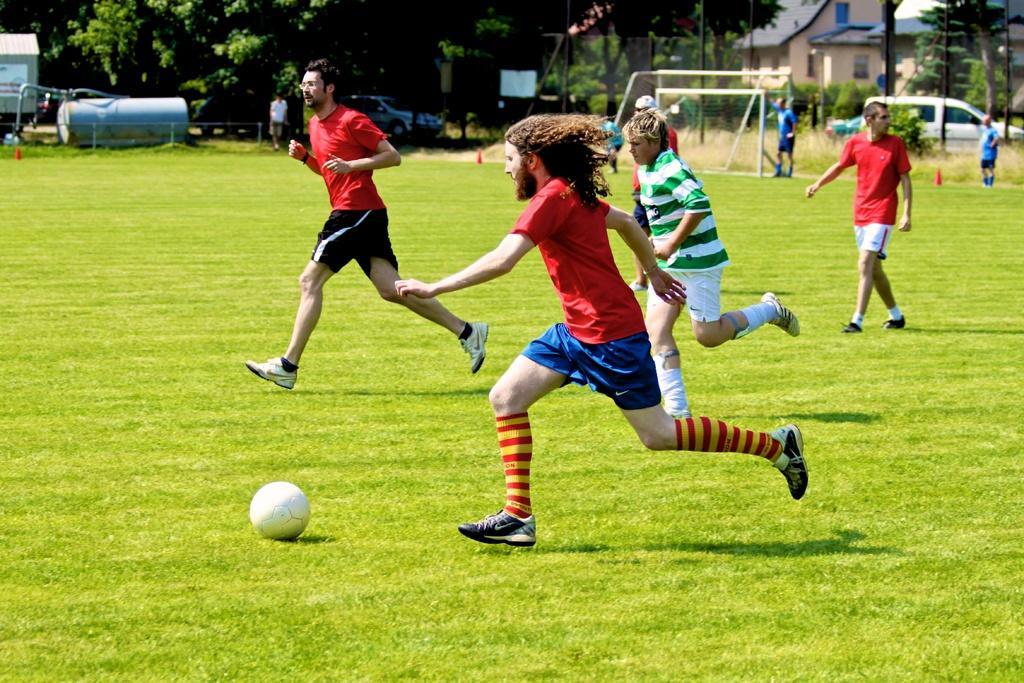How would you summarize this image in a sentence or two? In this image, I can see three persons running and a person walking. There is a football on the ground. In the background, I can see a football goal post, few people standing, vehicles, trees and there are buildings. 